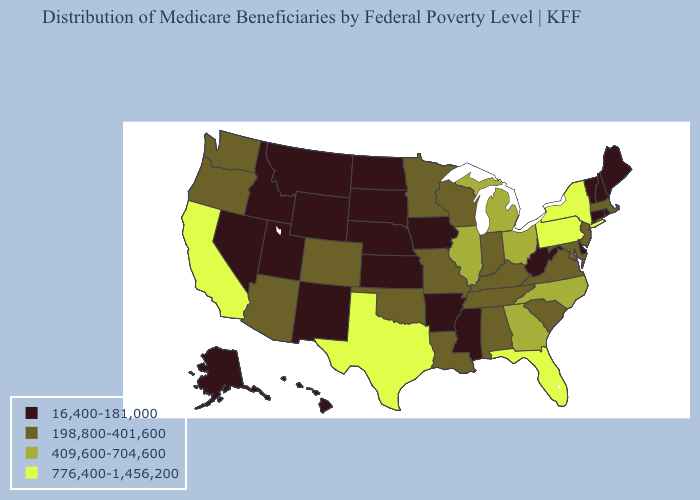Name the states that have a value in the range 776,400-1,456,200?
Be succinct. California, Florida, New York, Pennsylvania, Texas. Does Kentucky have a higher value than Georgia?
Be succinct. No. What is the value of Ohio?
Give a very brief answer. 409,600-704,600. What is the highest value in states that border Missouri?
Answer briefly. 409,600-704,600. How many symbols are there in the legend?
Quick response, please. 4. Name the states that have a value in the range 409,600-704,600?
Write a very short answer. Georgia, Illinois, Michigan, North Carolina, Ohio. Among the states that border Utah , does Colorado have the highest value?
Short answer required. Yes. Does Maine have the lowest value in the Northeast?
Be succinct. Yes. What is the value of Idaho?
Quick response, please. 16,400-181,000. Among the states that border West Virginia , does Pennsylvania have the highest value?
Short answer required. Yes. Does New Jersey have the highest value in the USA?
Give a very brief answer. No. Name the states that have a value in the range 198,800-401,600?
Quick response, please. Alabama, Arizona, Colorado, Indiana, Kentucky, Louisiana, Maryland, Massachusetts, Minnesota, Missouri, New Jersey, Oklahoma, Oregon, South Carolina, Tennessee, Virginia, Washington, Wisconsin. What is the lowest value in states that border Illinois?
Answer briefly. 16,400-181,000. What is the value of Oregon?
Give a very brief answer. 198,800-401,600. Does Massachusetts have the lowest value in the USA?
Quick response, please. No. 